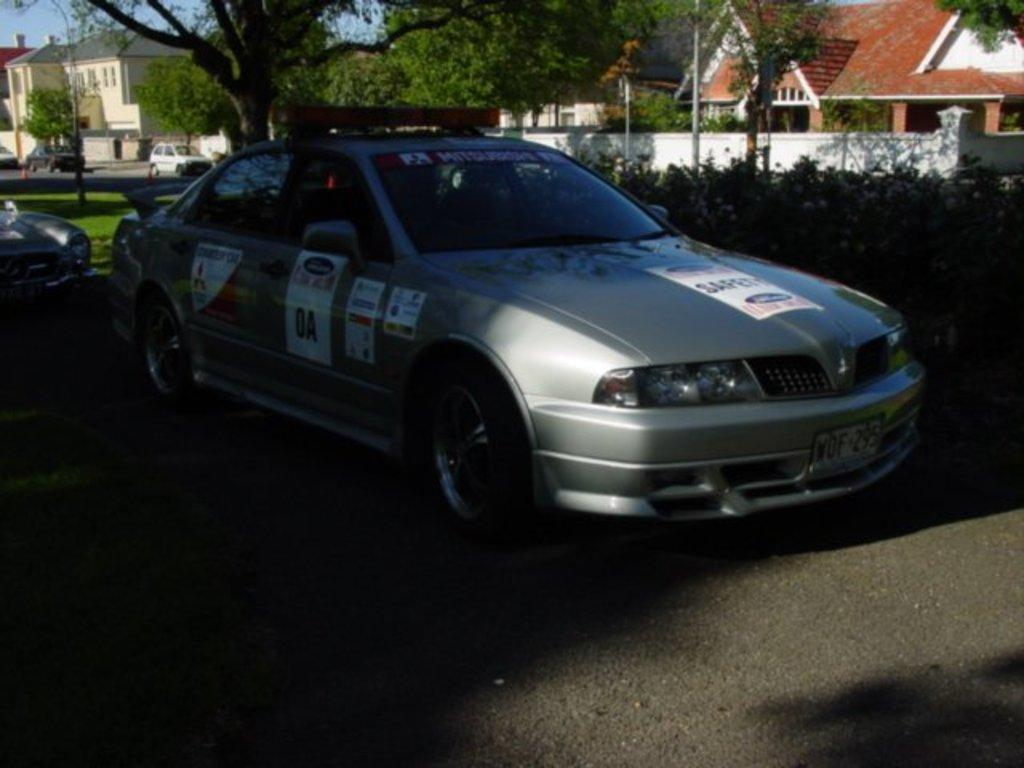What is parked under the tree in the image? There is a car parked under a tree in the image. What type of vegetation is visible in the image? There are many plants visible in the image. What can be seen in the background of the image? There are buildings in the background of the image. What colors are the buildings in the image? The buildings are in red and pale yellow colors. What color is the sky in the image? The sky is in pale blue color. Where is the nest of the bird in the image? There is no nest of a bird present in the image. What type of powder is used to clean the car in the image? There is no indication of any cleaning activity or powder in the image. 